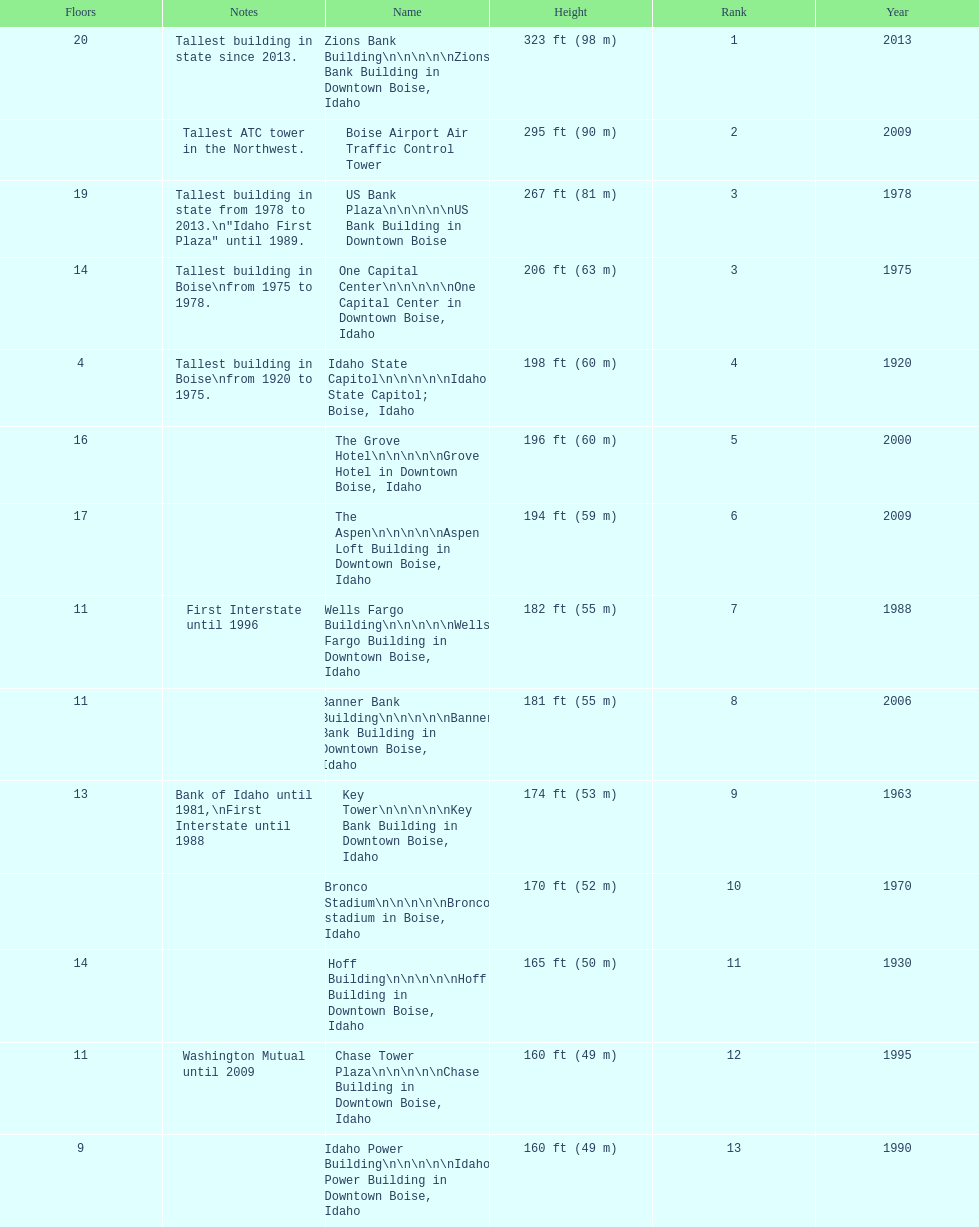Is the bronco stadium above or below 150 ft? Above. 